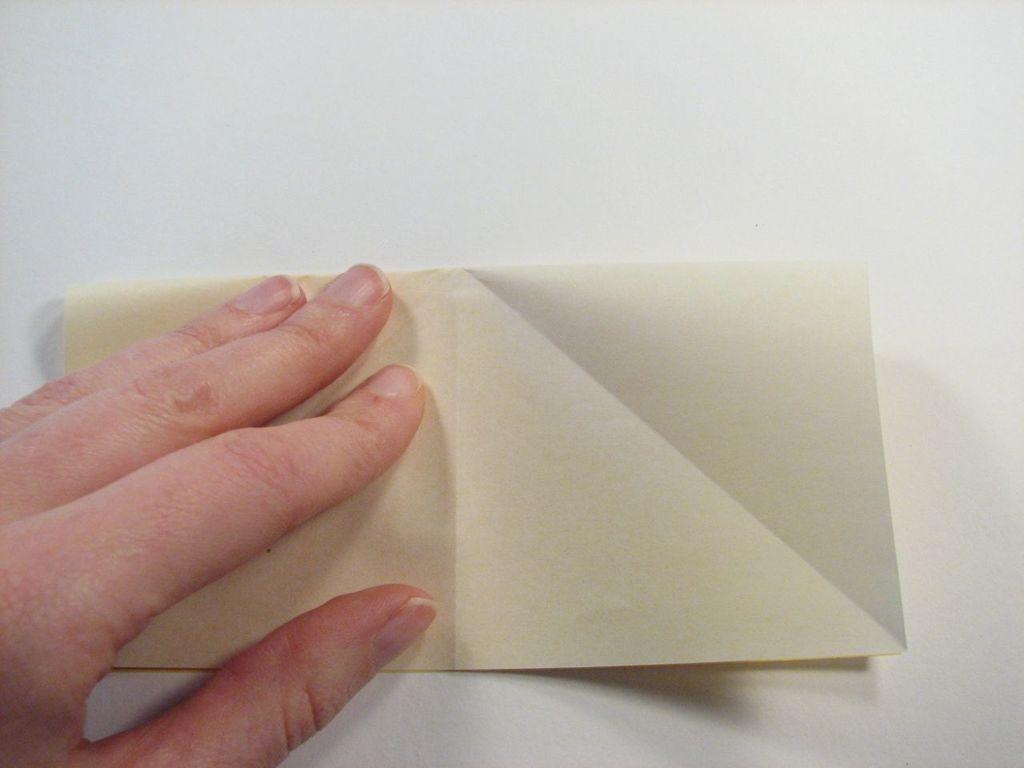Could you give a brief overview of what you see in this image? In the image we can see a human hand, this is a paper and a white surface. 